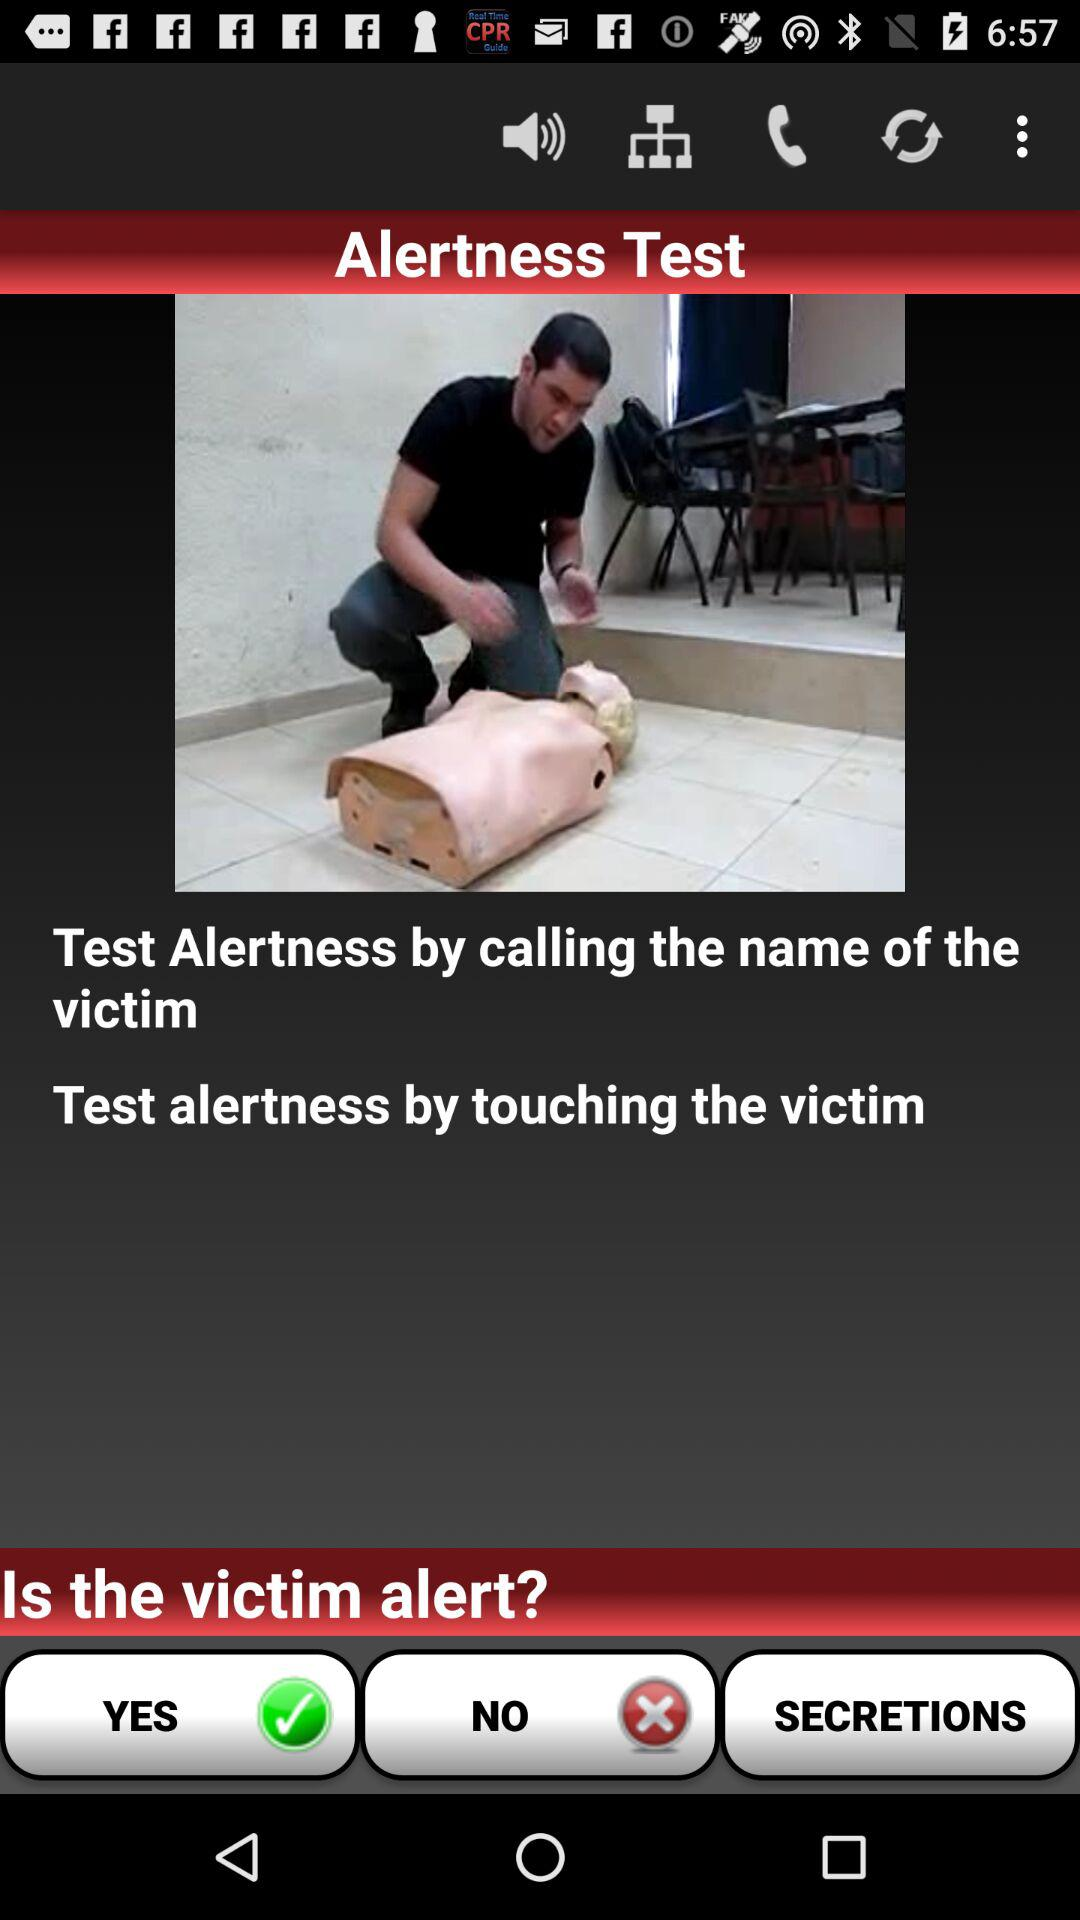How can alertness be tested? Alertness can be tested by calling the name of the victim and by touching the victim. 